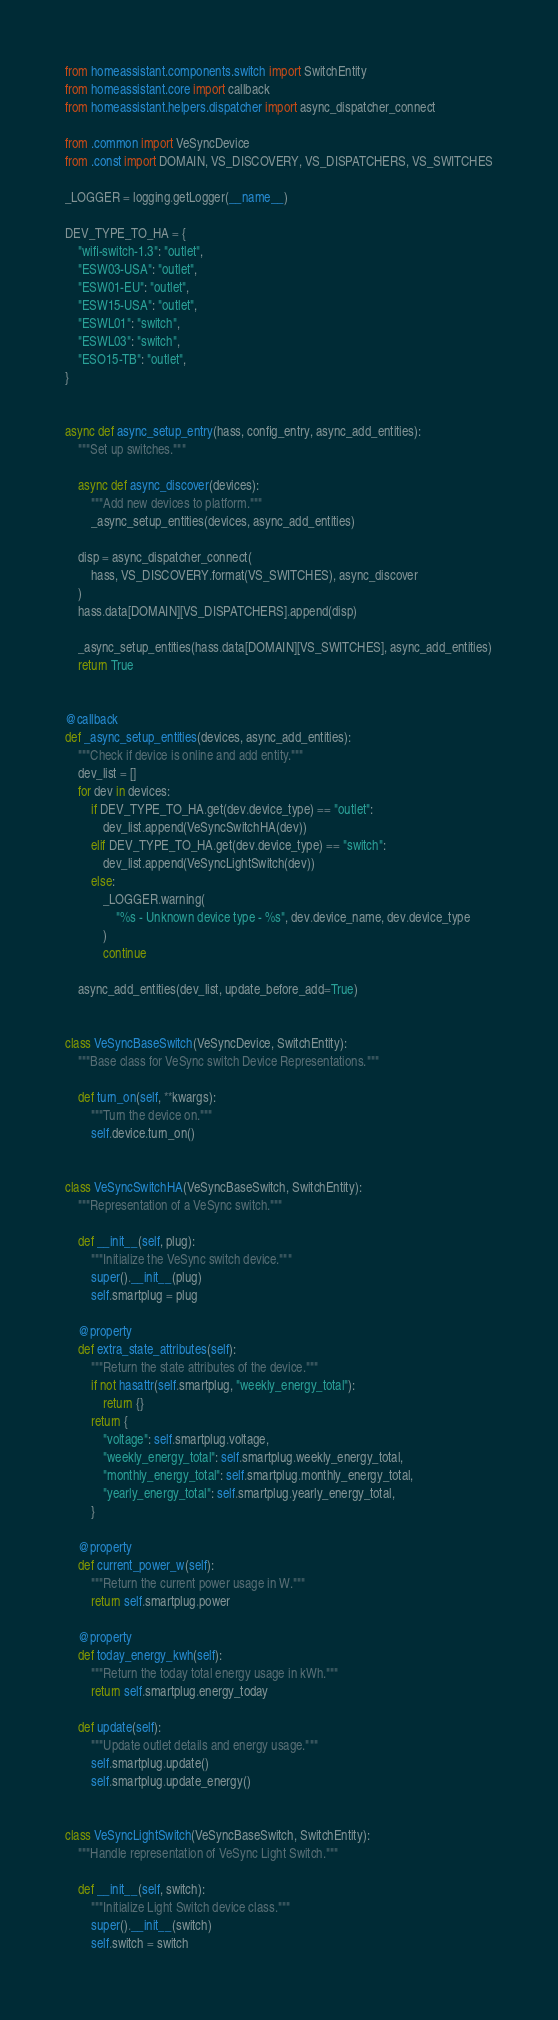<code> <loc_0><loc_0><loc_500><loc_500><_Python_>
from homeassistant.components.switch import SwitchEntity
from homeassistant.core import callback
from homeassistant.helpers.dispatcher import async_dispatcher_connect

from .common import VeSyncDevice
from .const import DOMAIN, VS_DISCOVERY, VS_DISPATCHERS, VS_SWITCHES

_LOGGER = logging.getLogger(__name__)

DEV_TYPE_TO_HA = {
    "wifi-switch-1.3": "outlet",
    "ESW03-USA": "outlet",
    "ESW01-EU": "outlet",
    "ESW15-USA": "outlet",
    "ESWL01": "switch",
    "ESWL03": "switch",
    "ESO15-TB": "outlet",
}


async def async_setup_entry(hass, config_entry, async_add_entities):
    """Set up switches."""

    async def async_discover(devices):
        """Add new devices to platform."""
        _async_setup_entities(devices, async_add_entities)

    disp = async_dispatcher_connect(
        hass, VS_DISCOVERY.format(VS_SWITCHES), async_discover
    )
    hass.data[DOMAIN][VS_DISPATCHERS].append(disp)

    _async_setup_entities(hass.data[DOMAIN][VS_SWITCHES], async_add_entities)
    return True


@callback
def _async_setup_entities(devices, async_add_entities):
    """Check if device is online and add entity."""
    dev_list = []
    for dev in devices:
        if DEV_TYPE_TO_HA.get(dev.device_type) == "outlet":
            dev_list.append(VeSyncSwitchHA(dev))
        elif DEV_TYPE_TO_HA.get(dev.device_type) == "switch":
            dev_list.append(VeSyncLightSwitch(dev))
        else:
            _LOGGER.warning(
                "%s - Unknown device type - %s", dev.device_name, dev.device_type
            )
            continue

    async_add_entities(dev_list, update_before_add=True)


class VeSyncBaseSwitch(VeSyncDevice, SwitchEntity):
    """Base class for VeSync switch Device Representations."""

    def turn_on(self, **kwargs):
        """Turn the device on."""
        self.device.turn_on()


class VeSyncSwitchHA(VeSyncBaseSwitch, SwitchEntity):
    """Representation of a VeSync switch."""

    def __init__(self, plug):
        """Initialize the VeSync switch device."""
        super().__init__(plug)
        self.smartplug = plug

    @property
    def extra_state_attributes(self):
        """Return the state attributes of the device."""
        if not hasattr(self.smartplug, "weekly_energy_total"):
            return {}
        return {
            "voltage": self.smartplug.voltage,
            "weekly_energy_total": self.smartplug.weekly_energy_total,
            "monthly_energy_total": self.smartplug.monthly_energy_total,
            "yearly_energy_total": self.smartplug.yearly_energy_total,
        }

    @property
    def current_power_w(self):
        """Return the current power usage in W."""
        return self.smartplug.power

    @property
    def today_energy_kwh(self):
        """Return the today total energy usage in kWh."""
        return self.smartplug.energy_today

    def update(self):
        """Update outlet details and energy usage."""
        self.smartplug.update()
        self.smartplug.update_energy()


class VeSyncLightSwitch(VeSyncBaseSwitch, SwitchEntity):
    """Handle representation of VeSync Light Switch."""

    def __init__(self, switch):
        """Initialize Light Switch device class."""
        super().__init__(switch)
        self.switch = switch
</code> 